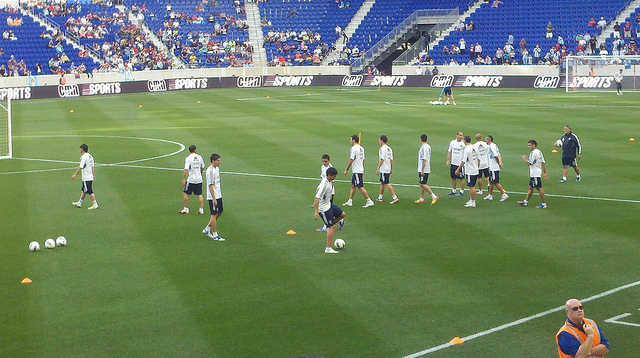Identify the text contained in this image. SPORTS SPORTS 